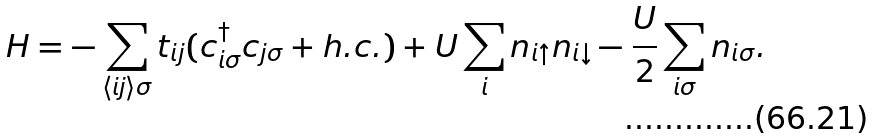Convert formula to latex. <formula><loc_0><loc_0><loc_500><loc_500>H = - \sum _ { \langle i j \rangle \sigma } t _ { i j } ( c _ { i \sigma } ^ { \dagger } c _ { j \sigma } + h . c . ) + U \sum _ { i } n _ { i \uparrow } n _ { i \downarrow } - \frac { U } { 2 } \sum _ { i \sigma } n _ { i \sigma } .</formula> 